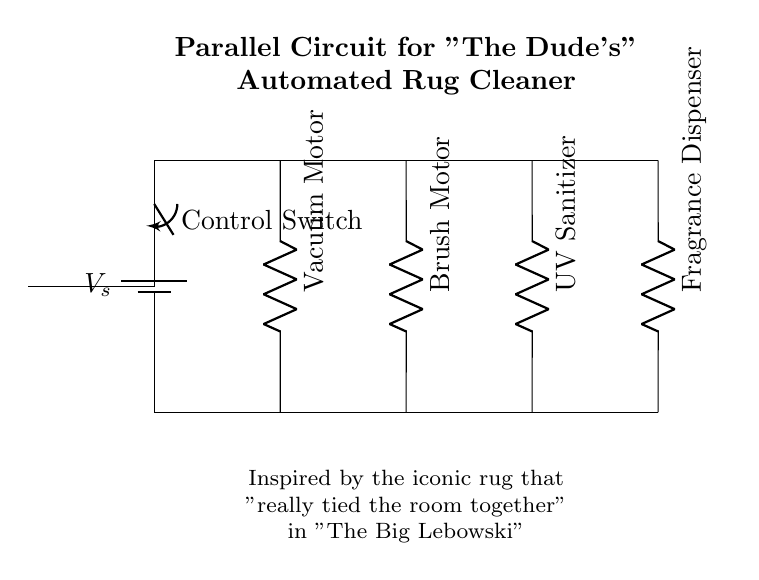What components are present in the circuit? The circuit includes a vacuum motor, brush motor, UV sanitizer, and fragrance dispenser, all connected in parallel. Each component is identified in the diagram as separate branches.
Answer: vacuum motor, brush motor, UV sanitizer, fragrance dispenser What type of circuit is this? The circuit is a parallel circuit, which can be observed by the configuration where each component has its own branch connected directly to the voltage source.
Answer: parallel How many branches are there in this circuit? There are four branches, each corresponding to a different component: vacuum motor, brush motor, UV sanitizer, and fragrance dispenser.
Answer: four What is the function of the control switch? The control switch controls the power flow to the circuit, allowing or stopping the functionality of all connected components simultaneously.
Answer: Controls power flow If one component fails, what happens to the others? In a parallel circuit, if one component fails, the other components continue to function because each is connected independently to the power source.
Answer: Others continue to function What does the line labeled ‘Vs’ represent? The label 'Vs' represents the voltage supply, indicating the source voltage that powers all components of the circuit.
Answer: voltage supply 